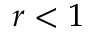<formula> <loc_0><loc_0><loc_500><loc_500>r < 1</formula> 